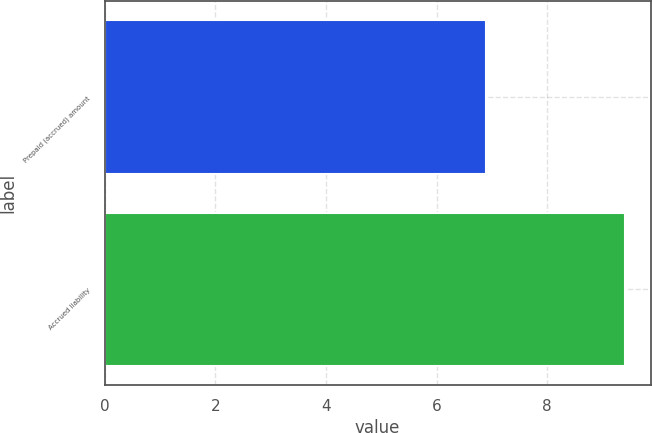<chart> <loc_0><loc_0><loc_500><loc_500><bar_chart><fcel>Prepaid (accrued) amount<fcel>Accrued liability<nl><fcel>6.9<fcel>9.4<nl></chart> 